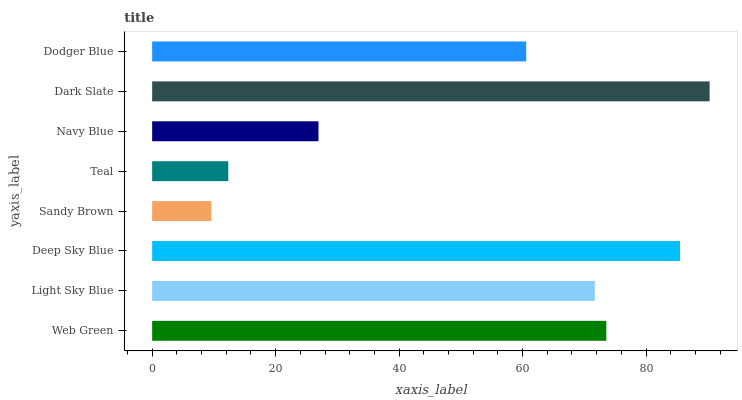Is Sandy Brown the minimum?
Answer yes or no. Yes. Is Dark Slate the maximum?
Answer yes or no. Yes. Is Light Sky Blue the minimum?
Answer yes or no. No. Is Light Sky Blue the maximum?
Answer yes or no. No. Is Web Green greater than Light Sky Blue?
Answer yes or no. Yes. Is Light Sky Blue less than Web Green?
Answer yes or no. Yes. Is Light Sky Blue greater than Web Green?
Answer yes or no. No. Is Web Green less than Light Sky Blue?
Answer yes or no. No. Is Light Sky Blue the high median?
Answer yes or no. Yes. Is Dodger Blue the low median?
Answer yes or no. Yes. Is Deep Sky Blue the high median?
Answer yes or no. No. Is Light Sky Blue the low median?
Answer yes or no. No. 